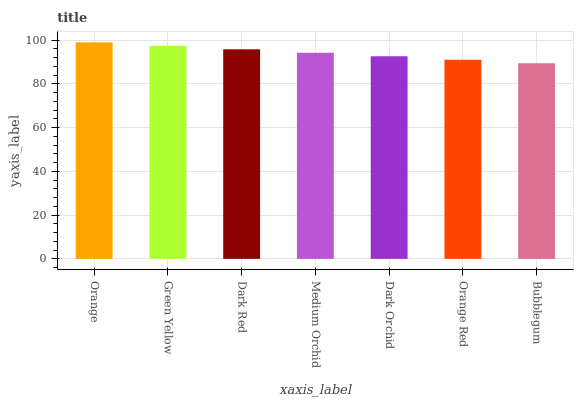Is Bubblegum the minimum?
Answer yes or no. Yes. Is Orange the maximum?
Answer yes or no. Yes. Is Green Yellow the minimum?
Answer yes or no. No. Is Green Yellow the maximum?
Answer yes or no. No. Is Orange greater than Green Yellow?
Answer yes or no. Yes. Is Green Yellow less than Orange?
Answer yes or no. Yes. Is Green Yellow greater than Orange?
Answer yes or no. No. Is Orange less than Green Yellow?
Answer yes or no. No. Is Medium Orchid the high median?
Answer yes or no. Yes. Is Medium Orchid the low median?
Answer yes or no. Yes. Is Bubblegum the high median?
Answer yes or no. No. Is Dark Orchid the low median?
Answer yes or no. No. 